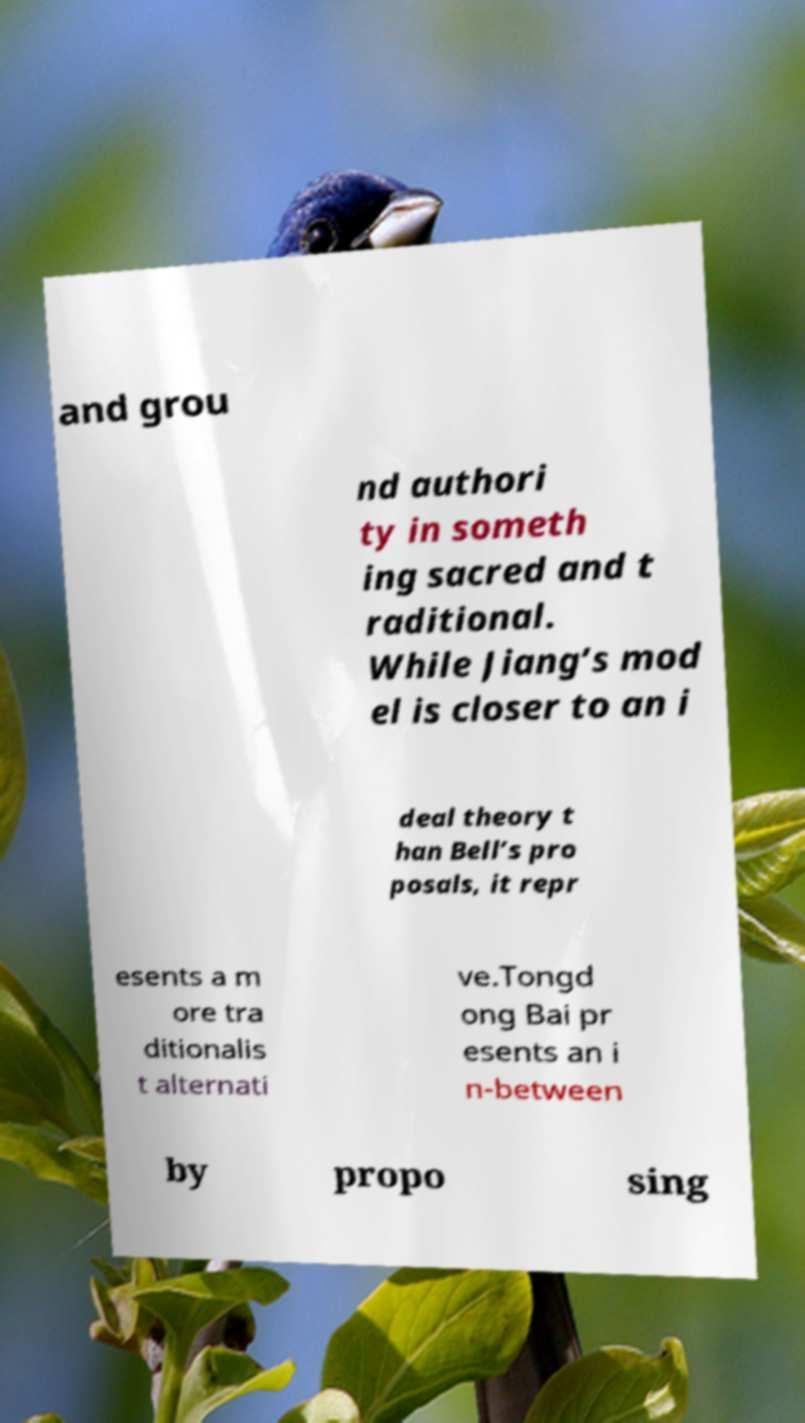What messages or text are displayed in this image? I need them in a readable, typed format. and grou nd authori ty in someth ing sacred and t raditional. While Jiang’s mod el is closer to an i deal theory t han Bell’s pro posals, it repr esents a m ore tra ditionalis t alternati ve.Tongd ong Bai pr esents an i n-between by propo sing 